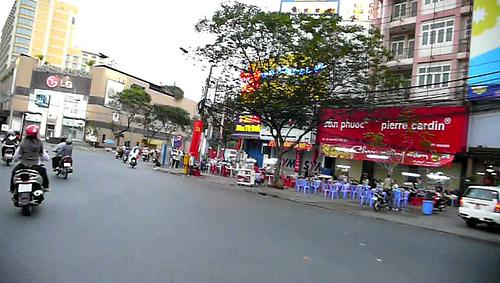Why is the motorcycle rider wearing a red helmet? protection 